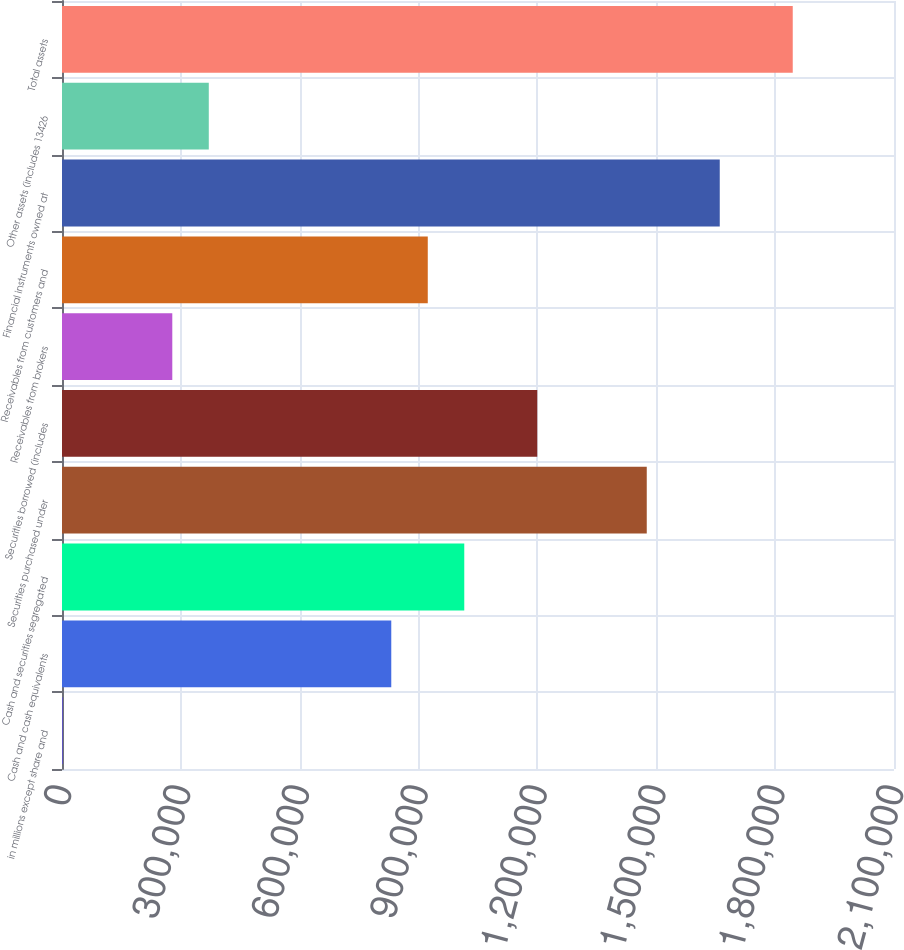Convert chart to OTSL. <chart><loc_0><loc_0><loc_500><loc_500><bar_chart><fcel>in millions except share and<fcel>Cash and cash equivalents<fcel>Cash and securities segregated<fcel>Securities purchased under<fcel>Securities borrowed (includes<fcel>Receivables from brokers<fcel>Receivables from customers and<fcel>Financial instruments owned at<fcel>Other assets (includes 13426<fcel>Total assets<nl><fcel>2011<fcel>831104<fcel>1.01535e+06<fcel>1.47595e+06<fcel>1.19959e+06<fcel>278375<fcel>923225<fcel>1.6602e+06<fcel>370497<fcel>1.84444e+06<nl></chart> 